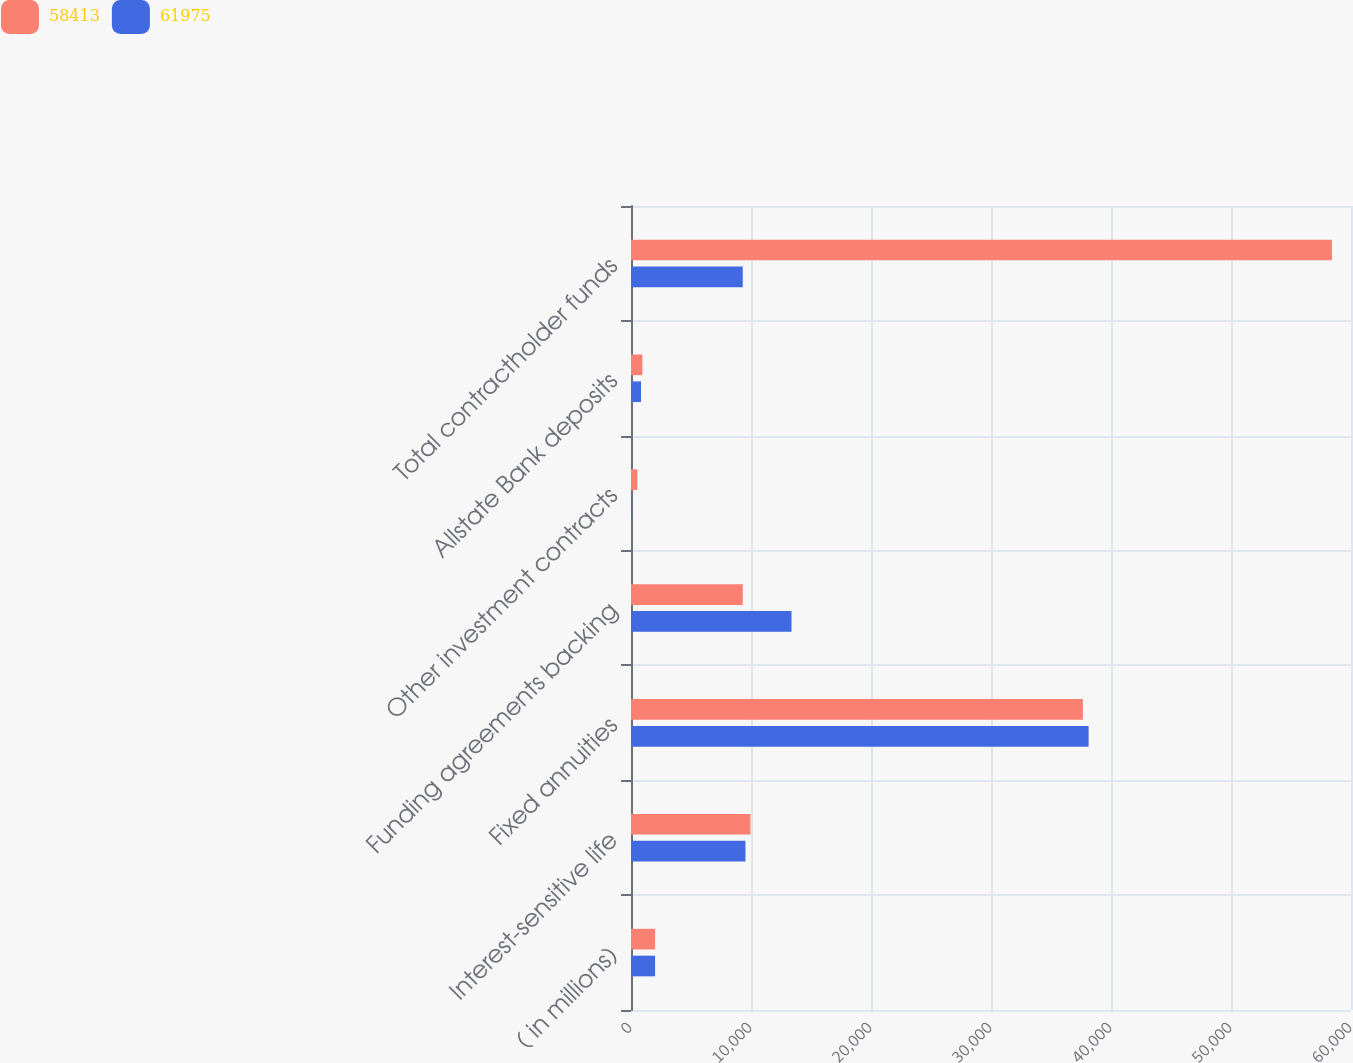<chart> <loc_0><loc_0><loc_500><loc_500><stacked_bar_chart><ecel><fcel>( in millions)<fcel>Interest-sensitive life<fcel>Fixed annuities<fcel>Funding agreements backing<fcel>Other investment contracts<fcel>Allstate Bank deposits<fcel>Total contractholder funds<nl><fcel>58413<fcel>2008<fcel>9957<fcel>37660<fcel>9314<fcel>533<fcel>949<fcel>58413<nl><fcel>61975<fcel>2007<fcel>9539<fcel>38135<fcel>13375<fcel>94<fcel>832<fcel>9314<nl></chart> 